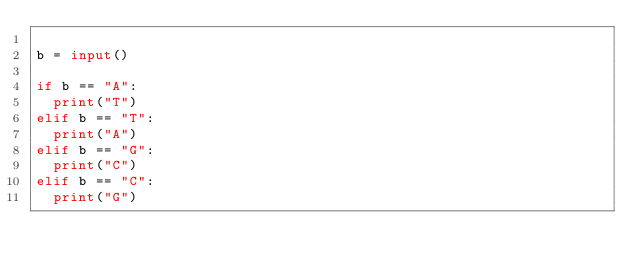Convert code to text. <code><loc_0><loc_0><loc_500><loc_500><_Python_>
b = input()

if b == "A":
  print("T")
elif b == "T":
  print("A")
elif b == "G":
  print("C")
elif b == "C":
  print("G")</code> 